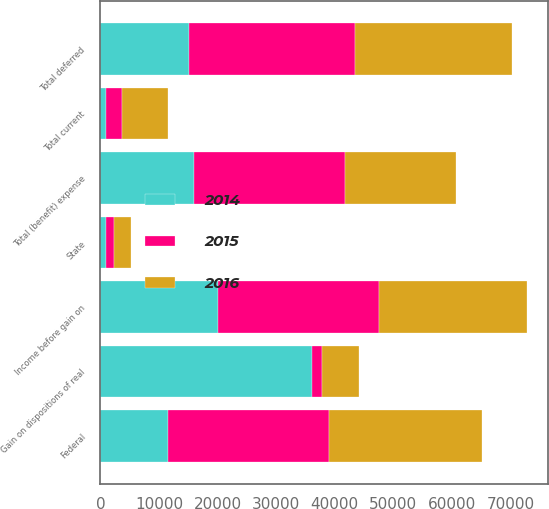Convert chart. <chart><loc_0><loc_0><loc_500><loc_500><stacked_bar_chart><ecel><fcel>State<fcel>Total current<fcel>Federal<fcel>Total deferred<fcel>Total (benefit) expense<fcel>Income before gain on<fcel>Gain on dispositions of real<nl><fcel>2016<fcel>2916<fcel>7954<fcel>26173<fcel>26796<fcel>18842<fcel>25208<fcel>6366<nl><fcel>2015<fcel>1357<fcel>2667<fcel>27382<fcel>28434<fcel>25767<fcel>27524<fcel>1757<nl><fcel>2014<fcel>970<fcel>970<fcel>11556<fcel>15041<fcel>16011<fcel>20047<fcel>36058<nl></chart> 